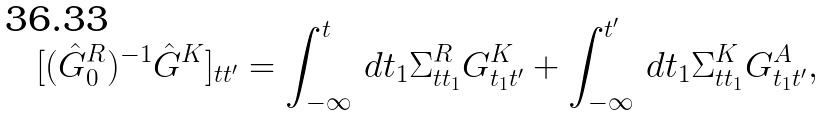<formula> <loc_0><loc_0><loc_500><loc_500>[ ( \hat { G } _ { 0 } ^ { R } ) ^ { - 1 } \hat { G } ^ { K } ] _ { t t ^ { \prime } } = \int _ { - \infty } ^ { t } \, d t _ { 1 } \Sigma ^ { R } _ { t t _ { 1 } } G ^ { K } _ { t _ { 1 } t ^ { \prime } } + \int _ { - \infty } ^ { t ^ { \prime } } \, d t _ { 1 } \Sigma ^ { K } _ { t t _ { 1 } } G ^ { A } _ { t _ { 1 } t ^ { \prime } } ,</formula> 